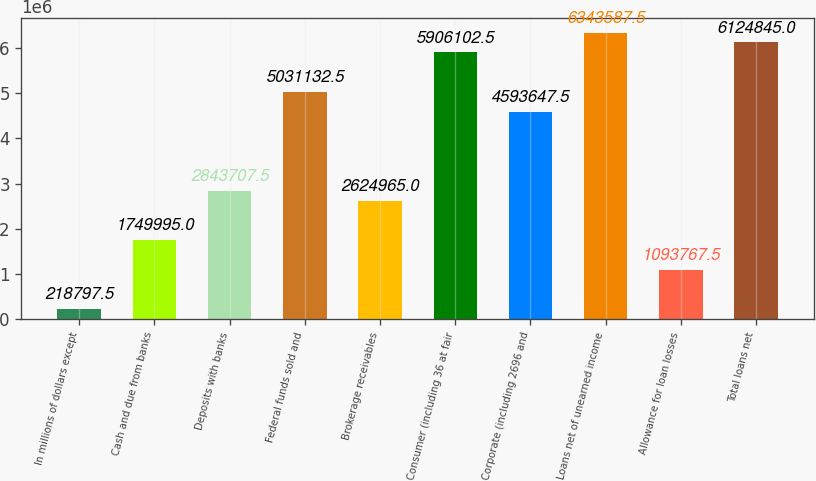Convert chart to OTSL. <chart><loc_0><loc_0><loc_500><loc_500><bar_chart><fcel>In millions of dollars except<fcel>Cash and due from banks<fcel>Deposits with banks<fcel>Federal funds sold and<fcel>Brokerage receivables<fcel>Consumer (including 36 at fair<fcel>Corporate (including 2696 and<fcel>Loans net of unearned income<fcel>Allowance for loan losses<fcel>Total loans net<nl><fcel>218798<fcel>1.75e+06<fcel>2.84371e+06<fcel>5.03113e+06<fcel>2.62496e+06<fcel>5.9061e+06<fcel>4.59365e+06<fcel>6.34359e+06<fcel>1.09377e+06<fcel>6.12484e+06<nl></chart> 